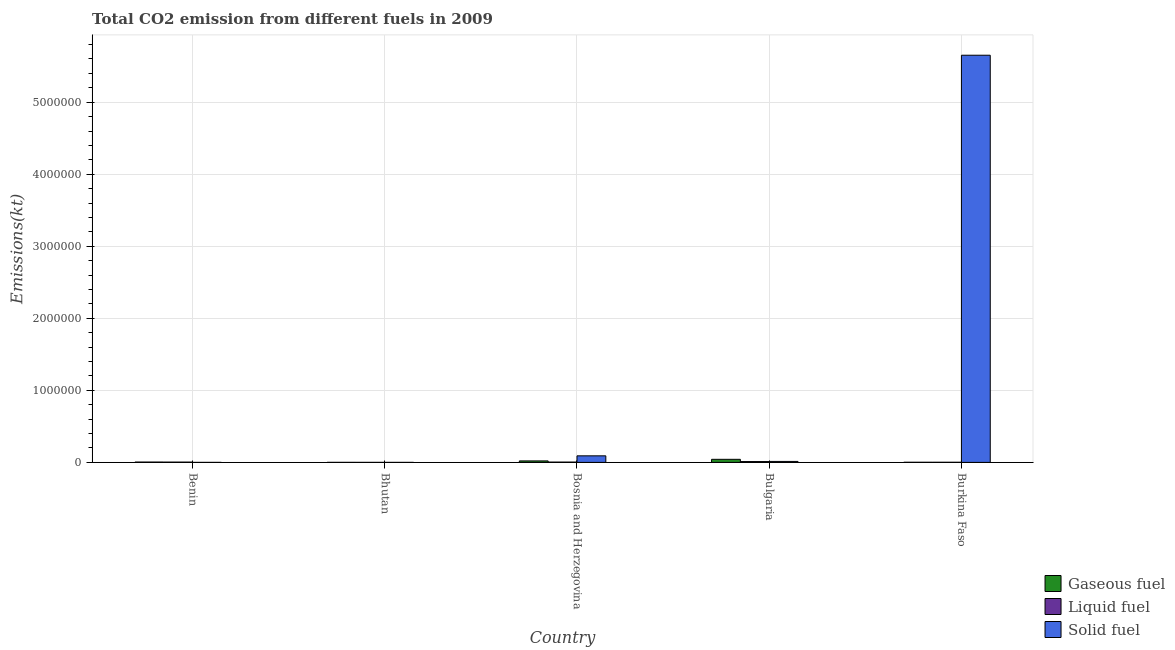How many different coloured bars are there?
Your response must be concise. 3. Are the number of bars on each tick of the X-axis equal?
Your response must be concise. Yes. How many bars are there on the 1st tick from the left?
Keep it short and to the point. 3. In how many cases, is the number of bars for a given country not equal to the number of legend labels?
Give a very brief answer. 0. What is the amount of co2 emissions from solid fuel in Bhutan?
Provide a succinct answer. 18.34. Across all countries, what is the maximum amount of co2 emissions from solid fuel?
Give a very brief answer. 5.65e+06. Across all countries, what is the minimum amount of co2 emissions from solid fuel?
Your answer should be very brief. 14.67. In which country was the amount of co2 emissions from liquid fuel maximum?
Provide a succinct answer. Bulgaria. In which country was the amount of co2 emissions from liquid fuel minimum?
Offer a very short reply. Bhutan. What is the total amount of co2 emissions from liquid fuel in the graph?
Provide a succinct answer. 2.19e+04. What is the difference between the amount of co2 emissions from liquid fuel in Benin and that in Bosnia and Herzegovina?
Offer a terse response. -396.04. What is the difference between the amount of co2 emissions from gaseous fuel in Bulgaria and the amount of co2 emissions from liquid fuel in Bosnia and Herzegovina?
Provide a short and direct response. 3.83e+04. What is the average amount of co2 emissions from liquid fuel per country?
Provide a short and direct response. 4376.93. What is the difference between the amount of co2 emissions from solid fuel and amount of co2 emissions from liquid fuel in Burkina Faso?
Your answer should be very brief. 5.65e+06. What is the ratio of the amount of co2 emissions from gaseous fuel in Benin to that in Bhutan?
Provide a short and direct response. 12.23. Is the amount of co2 emissions from gaseous fuel in Bosnia and Herzegovina less than that in Burkina Faso?
Provide a short and direct response. No. What is the difference between the highest and the second highest amount of co2 emissions from liquid fuel?
Make the answer very short. 7187.32. What is the difference between the highest and the lowest amount of co2 emissions from liquid fuel?
Ensure brevity in your answer.  1.13e+04. In how many countries, is the amount of co2 emissions from liquid fuel greater than the average amount of co2 emissions from liquid fuel taken over all countries?
Offer a terse response. 2. Is the sum of the amount of co2 emissions from liquid fuel in Benin and Bosnia and Herzegovina greater than the maximum amount of co2 emissions from gaseous fuel across all countries?
Make the answer very short. No. What does the 1st bar from the left in Burkina Faso represents?
Ensure brevity in your answer.  Gaseous fuel. What does the 1st bar from the right in Burkina Faso represents?
Keep it short and to the point. Solid fuel. How many bars are there?
Ensure brevity in your answer.  15. Are all the bars in the graph horizontal?
Give a very brief answer. No. How many countries are there in the graph?
Give a very brief answer. 5. What is the difference between two consecutive major ticks on the Y-axis?
Offer a very short reply. 1.00e+06. Are the values on the major ticks of Y-axis written in scientific E-notation?
Offer a terse response. No. Does the graph contain any zero values?
Your answer should be compact. No. How many legend labels are there?
Your answer should be very brief. 3. How are the legend labels stacked?
Your response must be concise. Vertical. What is the title of the graph?
Your answer should be very brief. Total CO2 emission from different fuels in 2009. Does "Slovak Republic" appear as one of the legend labels in the graph?
Your answer should be compact. No. What is the label or title of the Y-axis?
Keep it short and to the point. Emissions(kt). What is the Emissions(kt) in Gaseous fuel in Benin?
Offer a terse response. 4752.43. What is the Emissions(kt) of Liquid fuel in Benin?
Provide a succinct answer. 4004.36. What is the Emissions(kt) in Solid fuel in Benin?
Your response must be concise. 14.67. What is the Emissions(kt) of Gaseous fuel in Bhutan?
Offer a terse response. 388.7. What is the Emissions(kt) of Liquid fuel in Bhutan?
Make the answer very short. 242.02. What is the Emissions(kt) of Solid fuel in Bhutan?
Offer a very short reply. 18.34. What is the Emissions(kt) in Gaseous fuel in Bosnia and Herzegovina?
Your answer should be compact. 2.06e+04. What is the Emissions(kt) of Liquid fuel in Bosnia and Herzegovina?
Make the answer very short. 4400.4. What is the Emissions(kt) in Solid fuel in Bosnia and Herzegovina?
Make the answer very short. 9.11e+04. What is the Emissions(kt) of Gaseous fuel in Bulgaria?
Your answer should be compact. 4.27e+04. What is the Emissions(kt) of Liquid fuel in Bulgaria?
Ensure brevity in your answer.  1.16e+04. What is the Emissions(kt) of Solid fuel in Bulgaria?
Your answer should be compact. 1.34e+04. What is the Emissions(kt) of Gaseous fuel in Burkina Faso?
Make the answer very short. 1664.82. What is the Emissions(kt) in Liquid fuel in Burkina Faso?
Your answer should be very brief. 1650.15. What is the Emissions(kt) of Solid fuel in Burkina Faso?
Offer a terse response. 5.65e+06. Across all countries, what is the maximum Emissions(kt) of Gaseous fuel?
Your answer should be very brief. 4.27e+04. Across all countries, what is the maximum Emissions(kt) of Liquid fuel?
Your response must be concise. 1.16e+04. Across all countries, what is the maximum Emissions(kt) in Solid fuel?
Your answer should be very brief. 5.65e+06. Across all countries, what is the minimum Emissions(kt) of Gaseous fuel?
Give a very brief answer. 388.7. Across all countries, what is the minimum Emissions(kt) of Liquid fuel?
Ensure brevity in your answer.  242.02. Across all countries, what is the minimum Emissions(kt) in Solid fuel?
Your answer should be compact. 14.67. What is the total Emissions(kt) in Gaseous fuel in the graph?
Offer a very short reply. 7.01e+04. What is the total Emissions(kt) of Liquid fuel in the graph?
Make the answer very short. 2.19e+04. What is the total Emissions(kt) in Solid fuel in the graph?
Ensure brevity in your answer.  5.76e+06. What is the difference between the Emissions(kt) in Gaseous fuel in Benin and that in Bhutan?
Ensure brevity in your answer.  4363.73. What is the difference between the Emissions(kt) in Liquid fuel in Benin and that in Bhutan?
Ensure brevity in your answer.  3762.34. What is the difference between the Emissions(kt) in Solid fuel in Benin and that in Bhutan?
Your answer should be compact. -3.67. What is the difference between the Emissions(kt) in Gaseous fuel in Benin and that in Bosnia and Herzegovina?
Offer a very short reply. -1.59e+04. What is the difference between the Emissions(kt) in Liquid fuel in Benin and that in Bosnia and Herzegovina?
Provide a short and direct response. -396.04. What is the difference between the Emissions(kt) of Solid fuel in Benin and that in Bosnia and Herzegovina?
Offer a terse response. -9.11e+04. What is the difference between the Emissions(kt) of Gaseous fuel in Benin and that in Bulgaria?
Provide a short and direct response. -3.79e+04. What is the difference between the Emissions(kt) of Liquid fuel in Benin and that in Bulgaria?
Ensure brevity in your answer.  -7583.36. What is the difference between the Emissions(kt) in Solid fuel in Benin and that in Bulgaria?
Your answer should be compact. -1.34e+04. What is the difference between the Emissions(kt) of Gaseous fuel in Benin and that in Burkina Faso?
Make the answer very short. 3087.61. What is the difference between the Emissions(kt) in Liquid fuel in Benin and that in Burkina Faso?
Offer a terse response. 2354.21. What is the difference between the Emissions(kt) of Solid fuel in Benin and that in Burkina Faso?
Keep it short and to the point. -5.65e+06. What is the difference between the Emissions(kt) of Gaseous fuel in Bhutan and that in Bosnia and Herzegovina?
Provide a short and direct response. -2.02e+04. What is the difference between the Emissions(kt) in Liquid fuel in Bhutan and that in Bosnia and Herzegovina?
Offer a terse response. -4158.38. What is the difference between the Emissions(kt) in Solid fuel in Bhutan and that in Bosnia and Herzegovina?
Your response must be concise. -9.11e+04. What is the difference between the Emissions(kt) of Gaseous fuel in Bhutan and that in Bulgaria?
Give a very brief answer. -4.23e+04. What is the difference between the Emissions(kt) of Liquid fuel in Bhutan and that in Bulgaria?
Ensure brevity in your answer.  -1.13e+04. What is the difference between the Emissions(kt) in Solid fuel in Bhutan and that in Bulgaria?
Ensure brevity in your answer.  -1.34e+04. What is the difference between the Emissions(kt) of Gaseous fuel in Bhutan and that in Burkina Faso?
Your answer should be compact. -1276.12. What is the difference between the Emissions(kt) in Liquid fuel in Bhutan and that in Burkina Faso?
Offer a very short reply. -1408.13. What is the difference between the Emissions(kt) in Solid fuel in Bhutan and that in Burkina Faso?
Ensure brevity in your answer.  -5.65e+06. What is the difference between the Emissions(kt) in Gaseous fuel in Bosnia and Herzegovina and that in Bulgaria?
Keep it short and to the point. -2.20e+04. What is the difference between the Emissions(kt) of Liquid fuel in Bosnia and Herzegovina and that in Bulgaria?
Give a very brief answer. -7187.32. What is the difference between the Emissions(kt) of Solid fuel in Bosnia and Herzegovina and that in Bulgaria?
Offer a terse response. 7.77e+04. What is the difference between the Emissions(kt) in Gaseous fuel in Bosnia and Herzegovina and that in Burkina Faso?
Your response must be concise. 1.90e+04. What is the difference between the Emissions(kt) in Liquid fuel in Bosnia and Herzegovina and that in Burkina Faso?
Provide a succinct answer. 2750.25. What is the difference between the Emissions(kt) of Solid fuel in Bosnia and Herzegovina and that in Burkina Faso?
Your answer should be very brief. -5.56e+06. What is the difference between the Emissions(kt) of Gaseous fuel in Bulgaria and that in Burkina Faso?
Your answer should be very brief. 4.10e+04. What is the difference between the Emissions(kt) of Liquid fuel in Bulgaria and that in Burkina Faso?
Make the answer very short. 9937.57. What is the difference between the Emissions(kt) of Solid fuel in Bulgaria and that in Burkina Faso?
Ensure brevity in your answer.  -5.64e+06. What is the difference between the Emissions(kt) in Gaseous fuel in Benin and the Emissions(kt) in Liquid fuel in Bhutan?
Give a very brief answer. 4510.41. What is the difference between the Emissions(kt) in Gaseous fuel in Benin and the Emissions(kt) in Solid fuel in Bhutan?
Give a very brief answer. 4734.1. What is the difference between the Emissions(kt) of Liquid fuel in Benin and the Emissions(kt) of Solid fuel in Bhutan?
Offer a terse response. 3986.03. What is the difference between the Emissions(kt) in Gaseous fuel in Benin and the Emissions(kt) in Liquid fuel in Bosnia and Herzegovina?
Your answer should be very brief. 352.03. What is the difference between the Emissions(kt) of Gaseous fuel in Benin and the Emissions(kt) of Solid fuel in Bosnia and Herzegovina?
Offer a terse response. -8.64e+04. What is the difference between the Emissions(kt) of Liquid fuel in Benin and the Emissions(kt) of Solid fuel in Bosnia and Herzegovina?
Keep it short and to the point. -8.71e+04. What is the difference between the Emissions(kt) in Gaseous fuel in Benin and the Emissions(kt) in Liquid fuel in Bulgaria?
Offer a very short reply. -6835.29. What is the difference between the Emissions(kt) in Gaseous fuel in Benin and the Emissions(kt) in Solid fuel in Bulgaria?
Keep it short and to the point. -8690.79. What is the difference between the Emissions(kt) of Liquid fuel in Benin and the Emissions(kt) of Solid fuel in Bulgaria?
Give a very brief answer. -9438.86. What is the difference between the Emissions(kt) in Gaseous fuel in Benin and the Emissions(kt) in Liquid fuel in Burkina Faso?
Your response must be concise. 3102.28. What is the difference between the Emissions(kt) of Gaseous fuel in Benin and the Emissions(kt) of Solid fuel in Burkina Faso?
Your answer should be compact. -5.65e+06. What is the difference between the Emissions(kt) in Liquid fuel in Benin and the Emissions(kt) in Solid fuel in Burkina Faso?
Offer a terse response. -5.65e+06. What is the difference between the Emissions(kt) in Gaseous fuel in Bhutan and the Emissions(kt) in Liquid fuel in Bosnia and Herzegovina?
Provide a short and direct response. -4011.7. What is the difference between the Emissions(kt) in Gaseous fuel in Bhutan and the Emissions(kt) in Solid fuel in Bosnia and Herzegovina?
Make the answer very short. -9.07e+04. What is the difference between the Emissions(kt) of Liquid fuel in Bhutan and the Emissions(kt) of Solid fuel in Bosnia and Herzegovina?
Ensure brevity in your answer.  -9.09e+04. What is the difference between the Emissions(kt) in Gaseous fuel in Bhutan and the Emissions(kt) in Liquid fuel in Bulgaria?
Ensure brevity in your answer.  -1.12e+04. What is the difference between the Emissions(kt) in Gaseous fuel in Bhutan and the Emissions(kt) in Solid fuel in Bulgaria?
Offer a very short reply. -1.31e+04. What is the difference between the Emissions(kt) of Liquid fuel in Bhutan and the Emissions(kt) of Solid fuel in Bulgaria?
Give a very brief answer. -1.32e+04. What is the difference between the Emissions(kt) in Gaseous fuel in Bhutan and the Emissions(kt) in Liquid fuel in Burkina Faso?
Make the answer very short. -1261.45. What is the difference between the Emissions(kt) of Gaseous fuel in Bhutan and the Emissions(kt) of Solid fuel in Burkina Faso?
Keep it short and to the point. -5.65e+06. What is the difference between the Emissions(kt) of Liquid fuel in Bhutan and the Emissions(kt) of Solid fuel in Burkina Faso?
Provide a succinct answer. -5.65e+06. What is the difference between the Emissions(kt) of Gaseous fuel in Bosnia and Herzegovina and the Emissions(kt) of Liquid fuel in Bulgaria?
Offer a very short reply. 9028.15. What is the difference between the Emissions(kt) of Gaseous fuel in Bosnia and Herzegovina and the Emissions(kt) of Solid fuel in Bulgaria?
Keep it short and to the point. 7172.65. What is the difference between the Emissions(kt) of Liquid fuel in Bosnia and Herzegovina and the Emissions(kt) of Solid fuel in Bulgaria?
Keep it short and to the point. -9042.82. What is the difference between the Emissions(kt) in Gaseous fuel in Bosnia and Herzegovina and the Emissions(kt) in Liquid fuel in Burkina Faso?
Offer a very short reply. 1.90e+04. What is the difference between the Emissions(kt) of Gaseous fuel in Bosnia and Herzegovina and the Emissions(kt) of Solid fuel in Burkina Faso?
Provide a succinct answer. -5.63e+06. What is the difference between the Emissions(kt) in Liquid fuel in Bosnia and Herzegovina and the Emissions(kt) in Solid fuel in Burkina Faso?
Ensure brevity in your answer.  -5.65e+06. What is the difference between the Emissions(kt) in Gaseous fuel in Bulgaria and the Emissions(kt) in Liquid fuel in Burkina Faso?
Make the answer very short. 4.10e+04. What is the difference between the Emissions(kt) of Gaseous fuel in Bulgaria and the Emissions(kt) of Solid fuel in Burkina Faso?
Your response must be concise. -5.61e+06. What is the difference between the Emissions(kt) of Liquid fuel in Bulgaria and the Emissions(kt) of Solid fuel in Burkina Faso?
Offer a very short reply. -5.64e+06. What is the average Emissions(kt) of Gaseous fuel per country?
Ensure brevity in your answer.  1.40e+04. What is the average Emissions(kt) of Liquid fuel per country?
Keep it short and to the point. 4376.93. What is the average Emissions(kt) of Solid fuel per country?
Your answer should be very brief. 1.15e+06. What is the difference between the Emissions(kt) in Gaseous fuel and Emissions(kt) in Liquid fuel in Benin?
Your answer should be very brief. 748.07. What is the difference between the Emissions(kt) of Gaseous fuel and Emissions(kt) of Solid fuel in Benin?
Make the answer very short. 4737.76. What is the difference between the Emissions(kt) of Liquid fuel and Emissions(kt) of Solid fuel in Benin?
Offer a very short reply. 3989.7. What is the difference between the Emissions(kt) of Gaseous fuel and Emissions(kt) of Liquid fuel in Bhutan?
Give a very brief answer. 146.68. What is the difference between the Emissions(kt) of Gaseous fuel and Emissions(kt) of Solid fuel in Bhutan?
Your response must be concise. 370.37. What is the difference between the Emissions(kt) of Liquid fuel and Emissions(kt) of Solid fuel in Bhutan?
Keep it short and to the point. 223.69. What is the difference between the Emissions(kt) of Gaseous fuel and Emissions(kt) of Liquid fuel in Bosnia and Herzegovina?
Keep it short and to the point. 1.62e+04. What is the difference between the Emissions(kt) in Gaseous fuel and Emissions(kt) in Solid fuel in Bosnia and Herzegovina?
Keep it short and to the point. -7.05e+04. What is the difference between the Emissions(kt) in Liquid fuel and Emissions(kt) in Solid fuel in Bosnia and Herzegovina?
Give a very brief answer. -8.67e+04. What is the difference between the Emissions(kt) of Gaseous fuel and Emissions(kt) of Liquid fuel in Bulgaria?
Keep it short and to the point. 3.11e+04. What is the difference between the Emissions(kt) in Gaseous fuel and Emissions(kt) in Solid fuel in Bulgaria?
Offer a very short reply. 2.92e+04. What is the difference between the Emissions(kt) of Liquid fuel and Emissions(kt) of Solid fuel in Bulgaria?
Offer a terse response. -1855.5. What is the difference between the Emissions(kt) in Gaseous fuel and Emissions(kt) in Liquid fuel in Burkina Faso?
Keep it short and to the point. 14.67. What is the difference between the Emissions(kt) in Gaseous fuel and Emissions(kt) in Solid fuel in Burkina Faso?
Offer a very short reply. -5.65e+06. What is the difference between the Emissions(kt) in Liquid fuel and Emissions(kt) in Solid fuel in Burkina Faso?
Ensure brevity in your answer.  -5.65e+06. What is the ratio of the Emissions(kt) in Gaseous fuel in Benin to that in Bhutan?
Your response must be concise. 12.23. What is the ratio of the Emissions(kt) in Liquid fuel in Benin to that in Bhutan?
Make the answer very short. 16.55. What is the ratio of the Emissions(kt) in Solid fuel in Benin to that in Bhutan?
Give a very brief answer. 0.8. What is the ratio of the Emissions(kt) of Gaseous fuel in Benin to that in Bosnia and Herzegovina?
Offer a terse response. 0.23. What is the ratio of the Emissions(kt) of Liquid fuel in Benin to that in Bosnia and Herzegovina?
Give a very brief answer. 0.91. What is the ratio of the Emissions(kt) in Solid fuel in Benin to that in Bosnia and Herzegovina?
Ensure brevity in your answer.  0. What is the ratio of the Emissions(kt) in Gaseous fuel in Benin to that in Bulgaria?
Your response must be concise. 0.11. What is the ratio of the Emissions(kt) in Liquid fuel in Benin to that in Bulgaria?
Ensure brevity in your answer.  0.35. What is the ratio of the Emissions(kt) of Solid fuel in Benin to that in Bulgaria?
Your answer should be very brief. 0. What is the ratio of the Emissions(kt) of Gaseous fuel in Benin to that in Burkina Faso?
Offer a very short reply. 2.85. What is the ratio of the Emissions(kt) of Liquid fuel in Benin to that in Burkina Faso?
Your response must be concise. 2.43. What is the ratio of the Emissions(kt) in Solid fuel in Benin to that in Burkina Faso?
Make the answer very short. 0. What is the ratio of the Emissions(kt) of Gaseous fuel in Bhutan to that in Bosnia and Herzegovina?
Offer a terse response. 0.02. What is the ratio of the Emissions(kt) of Liquid fuel in Bhutan to that in Bosnia and Herzegovina?
Your answer should be compact. 0.06. What is the ratio of the Emissions(kt) in Gaseous fuel in Bhutan to that in Bulgaria?
Offer a very short reply. 0.01. What is the ratio of the Emissions(kt) in Liquid fuel in Bhutan to that in Bulgaria?
Ensure brevity in your answer.  0.02. What is the ratio of the Emissions(kt) of Solid fuel in Bhutan to that in Bulgaria?
Your answer should be compact. 0. What is the ratio of the Emissions(kt) in Gaseous fuel in Bhutan to that in Burkina Faso?
Your answer should be very brief. 0.23. What is the ratio of the Emissions(kt) in Liquid fuel in Bhutan to that in Burkina Faso?
Provide a short and direct response. 0.15. What is the ratio of the Emissions(kt) of Solid fuel in Bhutan to that in Burkina Faso?
Your response must be concise. 0. What is the ratio of the Emissions(kt) in Gaseous fuel in Bosnia and Herzegovina to that in Bulgaria?
Your answer should be very brief. 0.48. What is the ratio of the Emissions(kt) of Liquid fuel in Bosnia and Herzegovina to that in Bulgaria?
Ensure brevity in your answer.  0.38. What is the ratio of the Emissions(kt) in Solid fuel in Bosnia and Herzegovina to that in Bulgaria?
Give a very brief answer. 6.78. What is the ratio of the Emissions(kt) of Gaseous fuel in Bosnia and Herzegovina to that in Burkina Faso?
Ensure brevity in your answer.  12.38. What is the ratio of the Emissions(kt) in Liquid fuel in Bosnia and Herzegovina to that in Burkina Faso?
Make the answer very short. 2.67. What is the ratio of the Emissions(kt) in Solid fuel in Bosnia and Herzegovina to that in Burkina Faso?
Provide a short and direct response. 0.02. What is the ratio of the Emissions(kt) in Gaseous fuel in Bulgaria to that in Burkina Faso?
Offer a very short reply. 25.62. What is the ratio of the Emissions(kt) in Liquid fuel in Bulgaria to that in Burkina Faso?
Provide a short and direct response. 7.02. What is the ratio of the Emissions(kt) of Solid fuel in Bulgaria to that in Burkina Faso?
Keep it short and to the point. 0. What is the difference between the highest and the second highest Emissions(kt) of Gaseous fuel?
Give a very brief answer. 2.20e+04. What is the difference between the highest and the second highest Emissions(kt) of Liquid fuel?
Keep it short and to the point. 7187.32. What is the difference between the highest and the second highest Emissions(kt) of Solid fuel?
Your answer should be compact. 5.56e+06. What is the difference between the highest and the lowest Emissions(kt) of Gaseous fuel?
Offer a very short reply. 4.23e+04. What is the difference between the highest and the lowest Emissions(kt) of Liquid fuel?
Make the answer very short. 1.13e+04. What is the difference between the highest and the lowest Emissions(kt) of Solid fuel?
Your answer should be compact. 5.65e+06. 